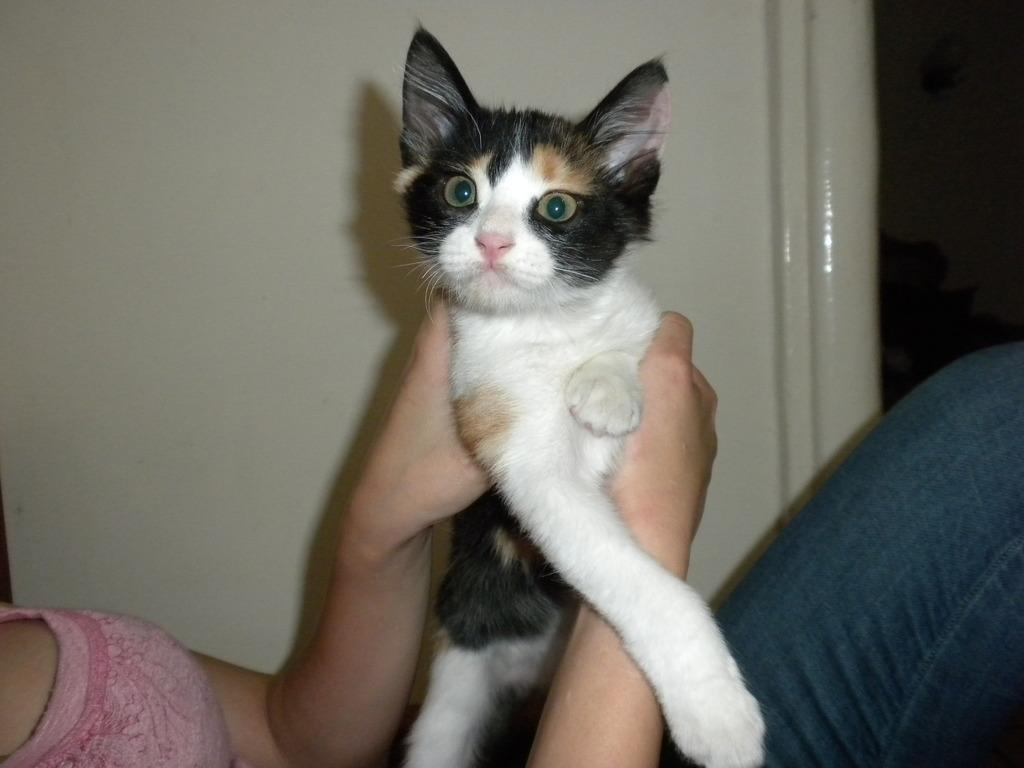What is the main subject of the image? There is a person in the image. What is the person holding in the image? The person is holding a cat. What type of sweater is the person wearing in the image? There is no information about a sweater in the image, so we cannot determine if the person is wearing one. 